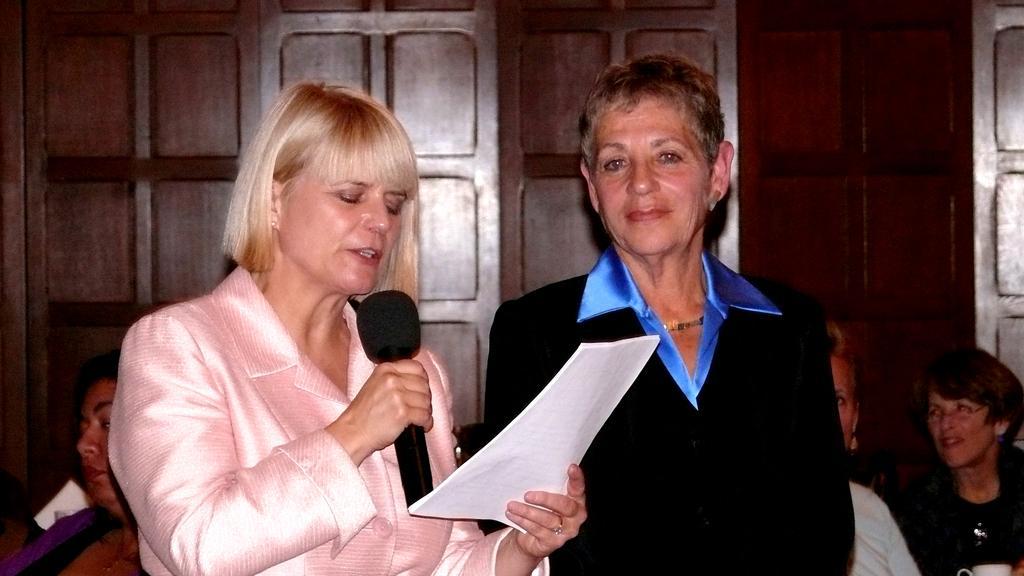In one or two sentences, can you explain what this image depicts? In this image i can see 2 women standing. the woman on the left side is holding a microphone and papers in her hand. In the background i can see few other people sitting. 